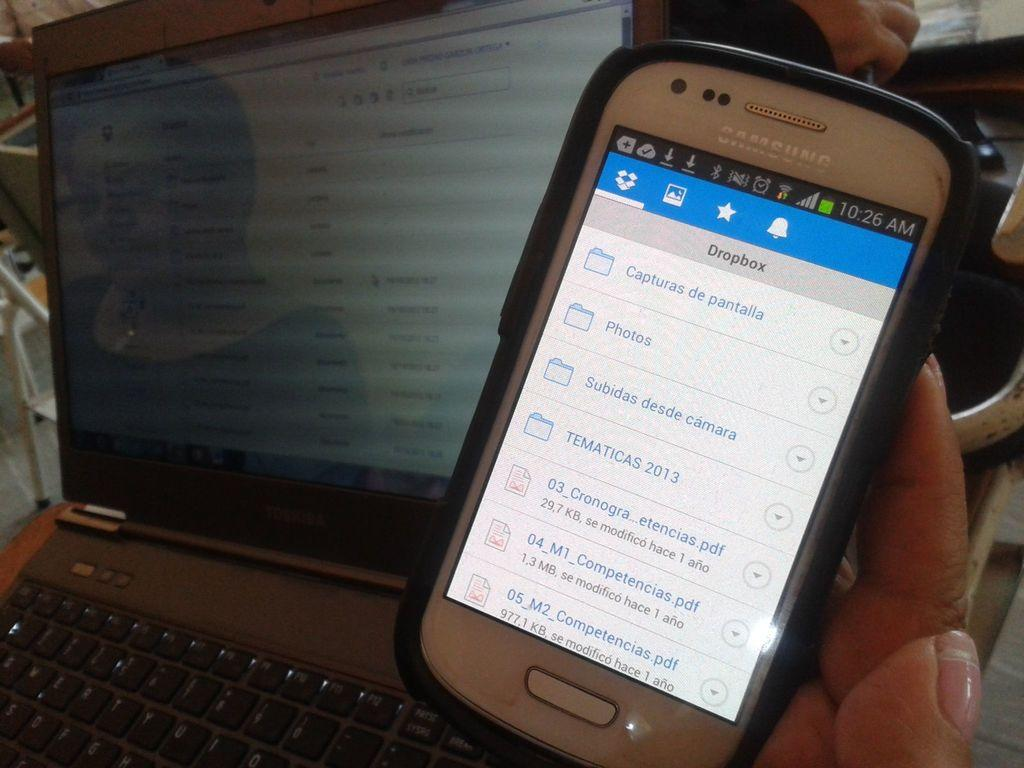Provide a one-sentence caption for the provided image. Someone holding a cellphone looking at their Dropbox scren. 